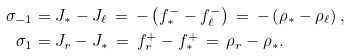<formula> <loc_0><loc_0><loc_500><loc_500>\sigma _ { - 1 } & = J _ { * } - J _ { \ell } \, = \, - \left ( f ^ { - } _ { * } - f ^ { - } _ { \ell } \right ) \, = \, - \left ( \rho _ { * } - \rho _ { \ell } \right ) , \\ \sigma _ { 1 } & = J _ { r } - J _ { * } \, = \, f ^ { + } _ { r } - f ^ { + } _ { * } \, = \, \rho _ { r } - \rho _ { * } .</formula> 